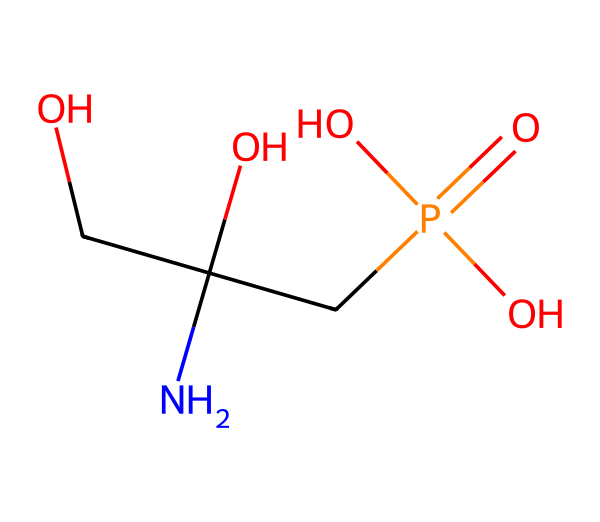What is the molecular formula of glyphosate? The chemical structure can be analyzed by counting the atoms for each element. The structure contains 3 carbon (C) atoms, 6 hydrogen (H) atoms, 1 nitrogen (N) atom, 4 oxygen (O) atoms, and 1 phosphorus (P) atom. Thus, the molecular formula is C3H8NO5P.
Answer: C3H8NO5P How many oxygen atoms are present in glyphosate? By examining the chemical structure, we can identify that there are four oxygen (O) atoms in glyphosate.
Answer: 4 What functional groups are present in glyphosate? Glyphosate features a phosphate group (due to the presence of phosphorus and oxygen atoms), an amine group (the nitrogen atom), and hydroxyl groups (the presence of OH groups).
Answer: phosphate, amine, hydroxyl Which atom in glyphosate is responsible for its herbicidal activity? The phosphorus atom is crucial in glyphosate as it is part of the phosphate group, which plays a key role in its mechanism of action as a herbicide, specifically in plant metabolic pathways.
Answer: phosphorus Explain how glyphosate’s structure influences its solubility in water. Glyphosate contains multiple polar functional groups, including hydroxyl and phosphate groups, which form hydrogen bonds with water molecules. This increases its solubility in water significantly.
Answer: polar functional groups What type of herbicide is glyphosate classified as? Glyphosate is classified as a systemic herbicide, which means it is absorbed through plant leaves and translocated to other parts of the plant to inhibit growth.
Answer: systemic herbicide 